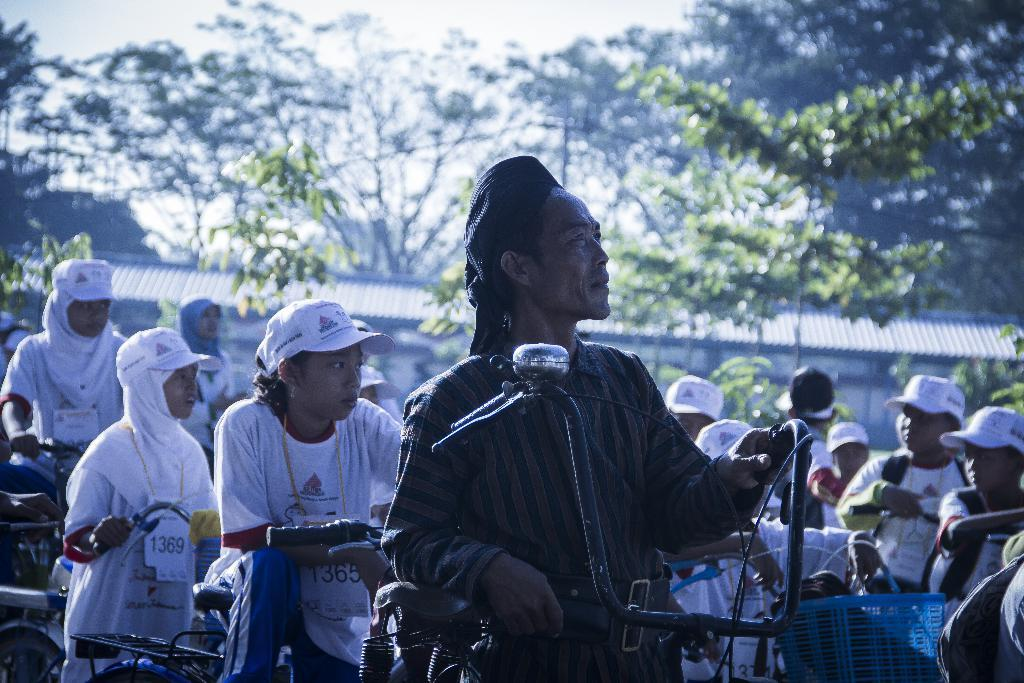Who or what can be seen in the image? There are people in the image. What are the people using in the image? There are bicycles in the image that the people might be using. What type of natural environment is visible in the image? There are trees in the image, indicating a natural setting. How many boats can be seen in the image? There are no boats present in the image. 